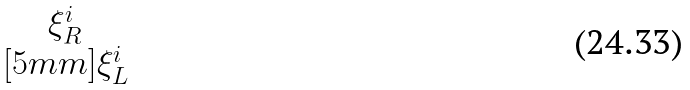<formula> <loc_0><loc_0><loc_500><loc_500>\begin{matrix} \xi _ { R } ^ { i } \\ [ 5 m m ] \xi _ { L } ^ { i } \end{matrix}</formula> 